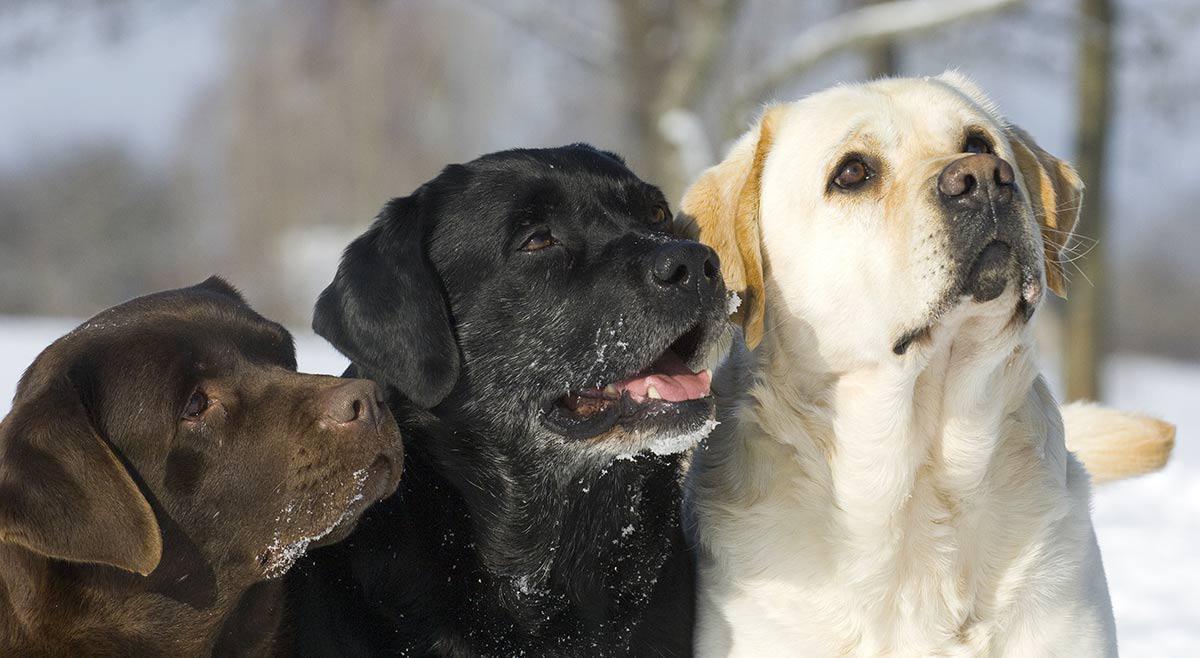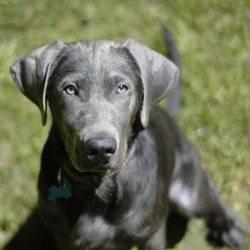The first image is the image on the left, the second image is the image on the right. Analyze the images presented: Is the assertion "An image shows three different solid color dogs posed side-by-side, with the black dog in the middle." valid? Answer yes or no. Yes. The first image is the image on the left, the second image is the image on the right. Given the left and right images, does the statement "The right image contains three dogs seated outside." hold true? Answer yes or no. No. 